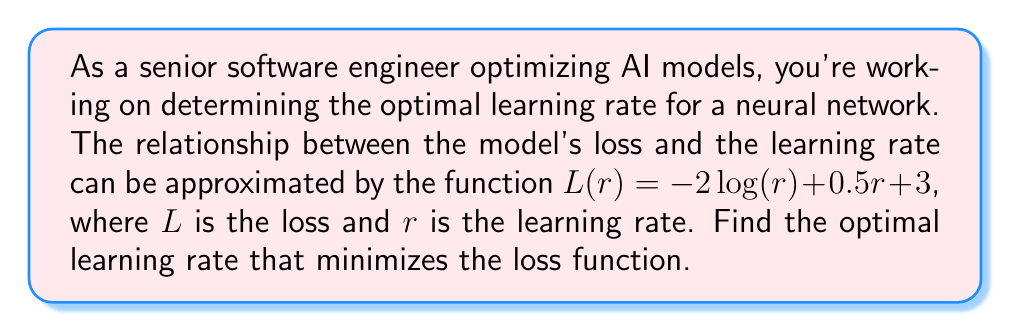Show me your answer to this math problem. To find the optimal learning rate, we need to determine the minimum point of the loss function. This can be done by following these steps:

1. Find the derivative of the loss function:
   $$L(r) = -2\log(r) + 0.5r + 3$$
   $$L'(r) = -\frac{2}{r} + 0.5$$

2. Set the derivative equal to zero to find the critical point:
   $$-\frac{2}{r} + 0.5 = 0$$

3. Solve for $r$:
   $$-\frac{2}{r} = -0.5$$
   $$\frac{2}{r} = 0.5$$
   $$2 = 0.5r$$
   $$r = \frac{2}{0.5} = 4$$

4. Verify that this critical point is a minimum by checking the second derivative:
   $$L''(r) = \frac{2}{r^2}$$
   $$L''(4) = \frac{2}{4^2} = \frac{1}{8} > 0$$

   Since the second derivative is positive at $r = 4$, this confirms that it is a local minimum.

5. Therefore, the optimal learning rate that minimizes the loss function is 4.
Answer: $4$ 